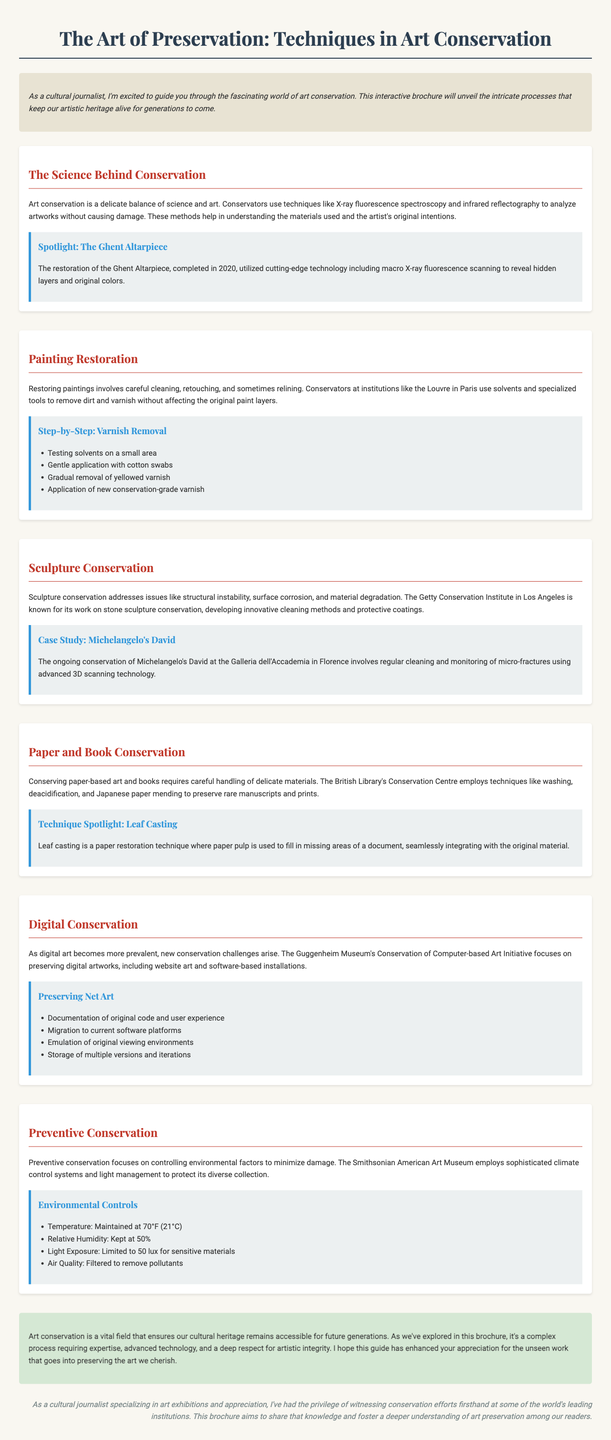what is the title of the brochure? The title is mentioned prominently at the top of the document.
Answer: The Art of Preservation: Techniques in Art Conservation who completed the restoration of the Ghent Altarpiece? The document specifies the year when the restoration was completed.
Answer: 2020 which institution is known for its work on stone sculpture conservation? The document highlights a prominent conservation institution in Los Angeles.
Answer: The Getty Conservation Institute what technique is used in leaf casting? The content explains a specific technique used in paper conservation.
Answer: Paper pulp what is the temperature maintained for preventive conservation? The section on environmental controls provides specific information about temperature settings.
Answer: 70°F (21°C) how many steps are detailed in the varnish removal process? The document lists the steps involved in this restoration technique.
Answer: Four steps what is a primary focus of digital conservation? The document outlines the specific challenges faced with digital art preservation.
Answer: Preserving digital artworks what is emphasized in preventive conservation? The document discusses the primary aim of this conservation approach.
Answer: Controlling environmental factors who is the author of the brochure? The document provides a brief mention of the author's background and expertise.
Answer: Cultural journalist 